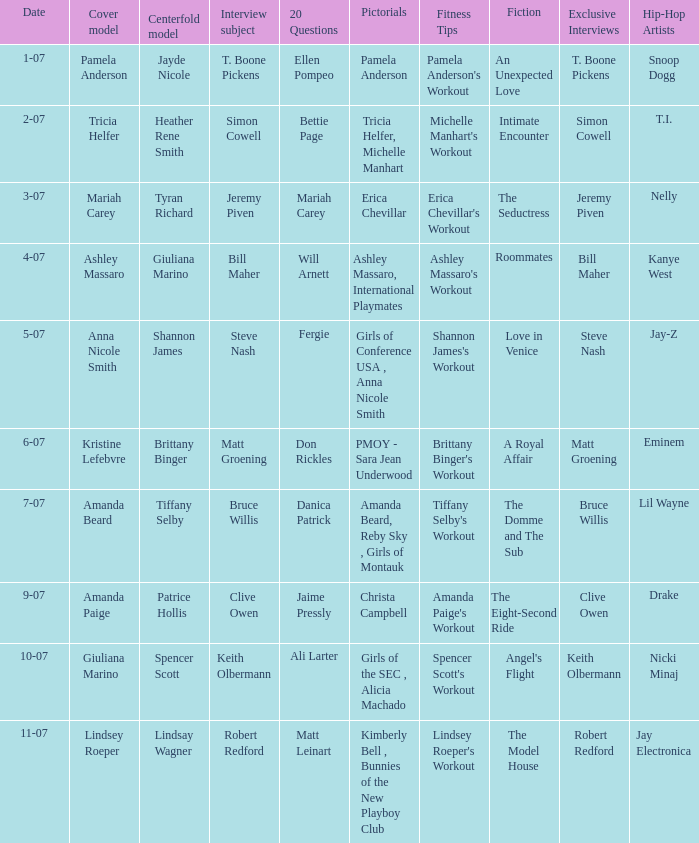Who answered the 20 questions on 10-07? Ali Larter. 